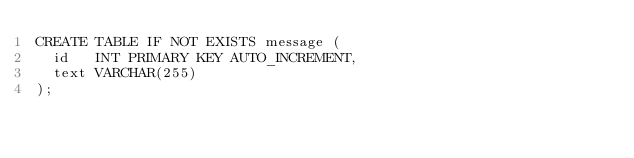<code> <loc_0><loc_0><loc_500><loc_500><_SQL_>CREATE TABLE IF NOT EXISTS message (
  id   INT PRIMARY KEY AUTO_INCREMENT,
  text VARCHAR(255)
);
</code> 